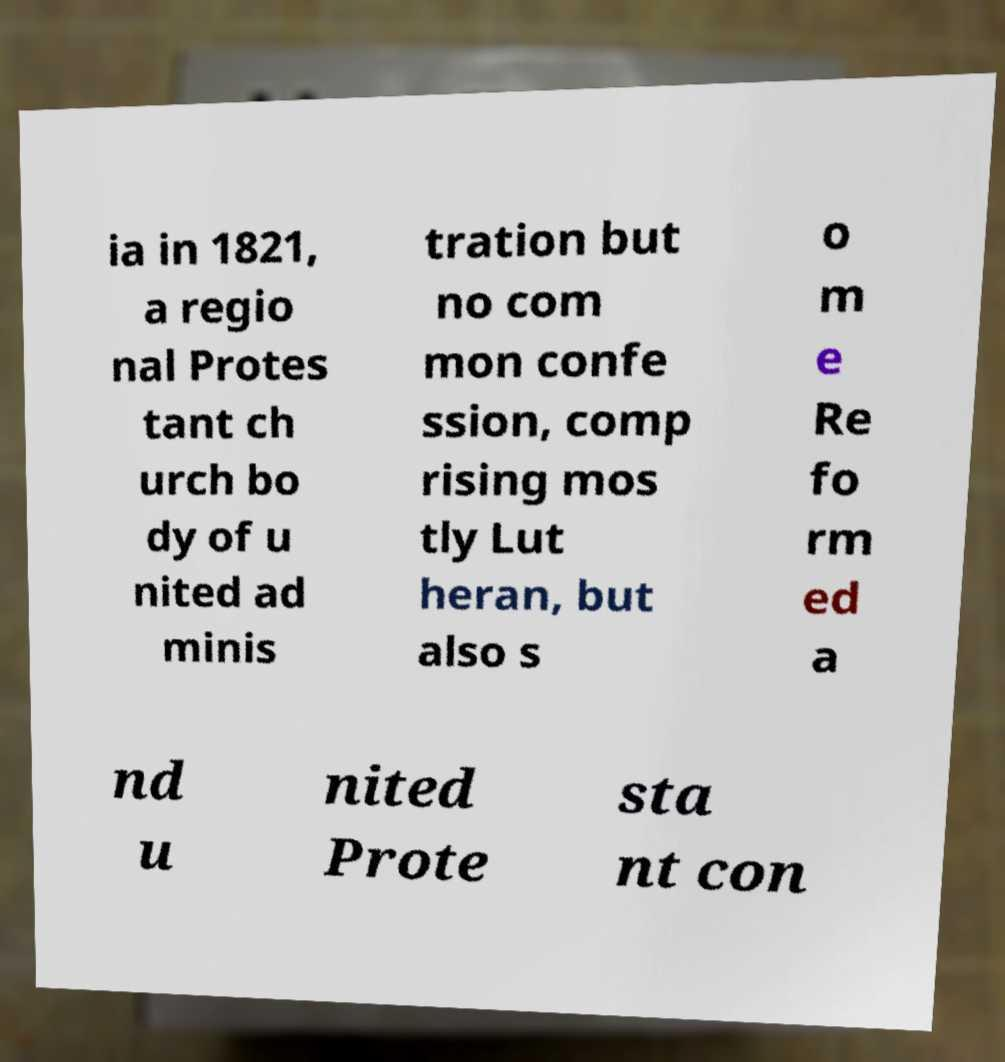Can you accurately transcribe the text from the provided image for me? ia in 1821, a regio nal Protes tant ch urch bo dy of u nited ad minis tration but no com mon confe ssion, comp rising mos tly Lut heran, but also s o m e Re fo rm ed a nd u nited Prote sta nt con 